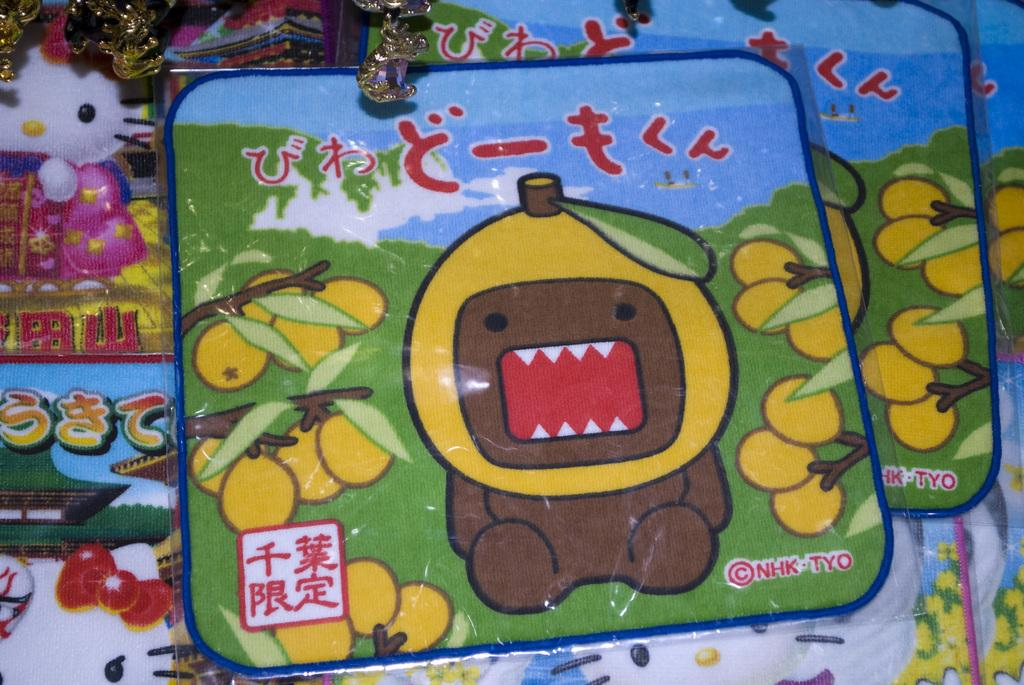What type of material is visible in the image? There are sheets in the image. How are the sheets protected in the image? The sheets are covered in plastic. What is the color scheme of the sheets? The sheets are colorful. What type of objects are at the top of the image? There are gold-colored objects in the image. What type of pancake is being stretched by the head in the image? There is no pancake or head present in the image. 